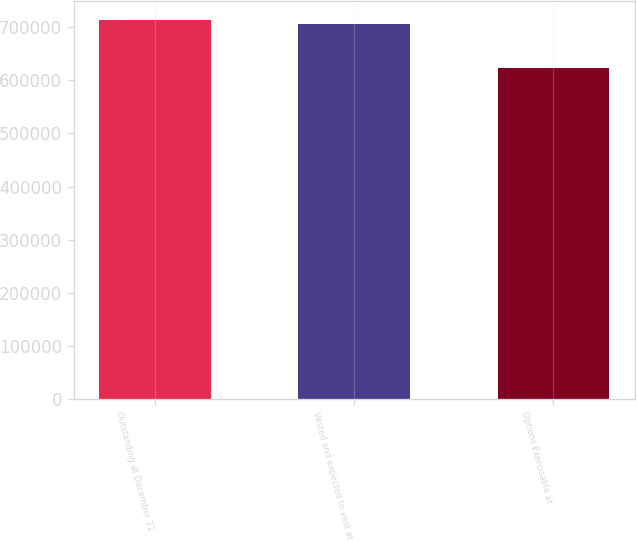Convert chart to OTSL. <chart><loc_0><loc_0><loc_500><loc_500><bar_chart><fcel>Outstanding at December 31<fcel>Vested and expected to vest at<fcel>Options Exercisable at<nl><fcel>713184<fcel>704796<fcel>622168<nl></chart> 